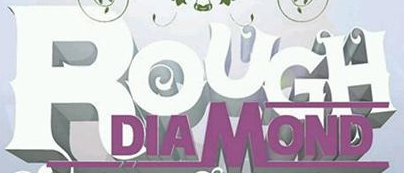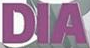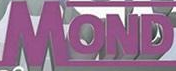Identify the words shown in these images in order, separated by a semicolon. ROUGH; DIA; MOND 